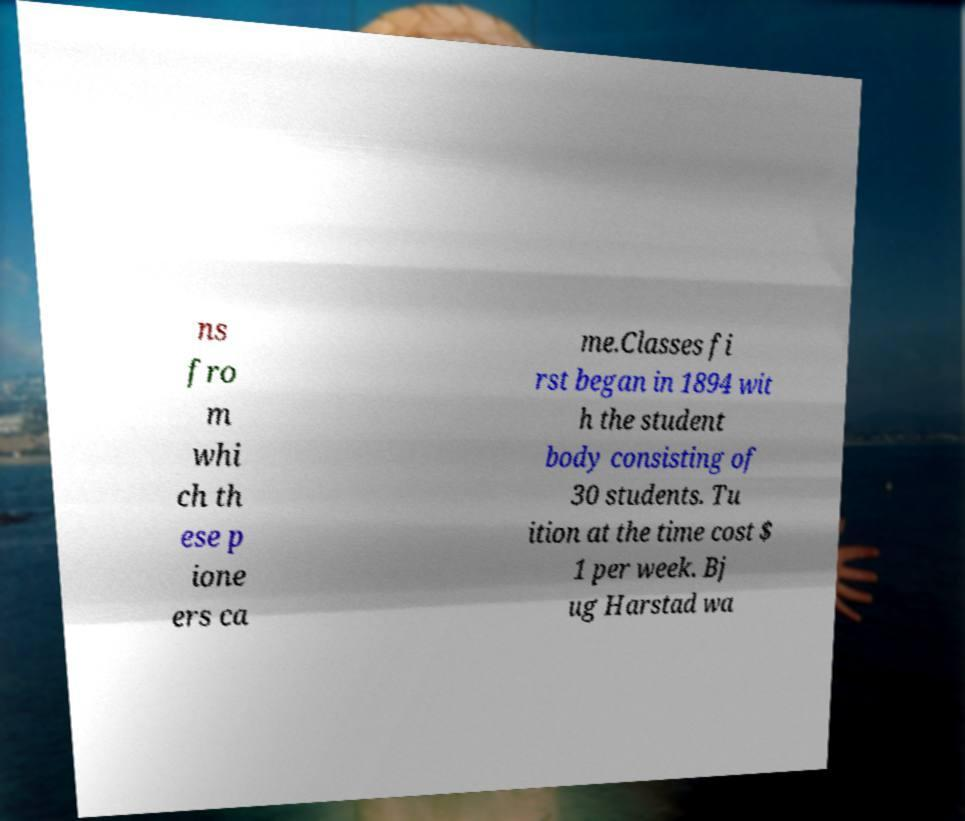What messages or text are displayed in this image? I need them in a readable, typed format. ns fro m whi ch th ese p ione ers ca me.Classes fi rst began in 1894 wit h the student body consisting of 30 students. Tu ition at the time cost $ 1 per week. Bj ug Harstad wa 